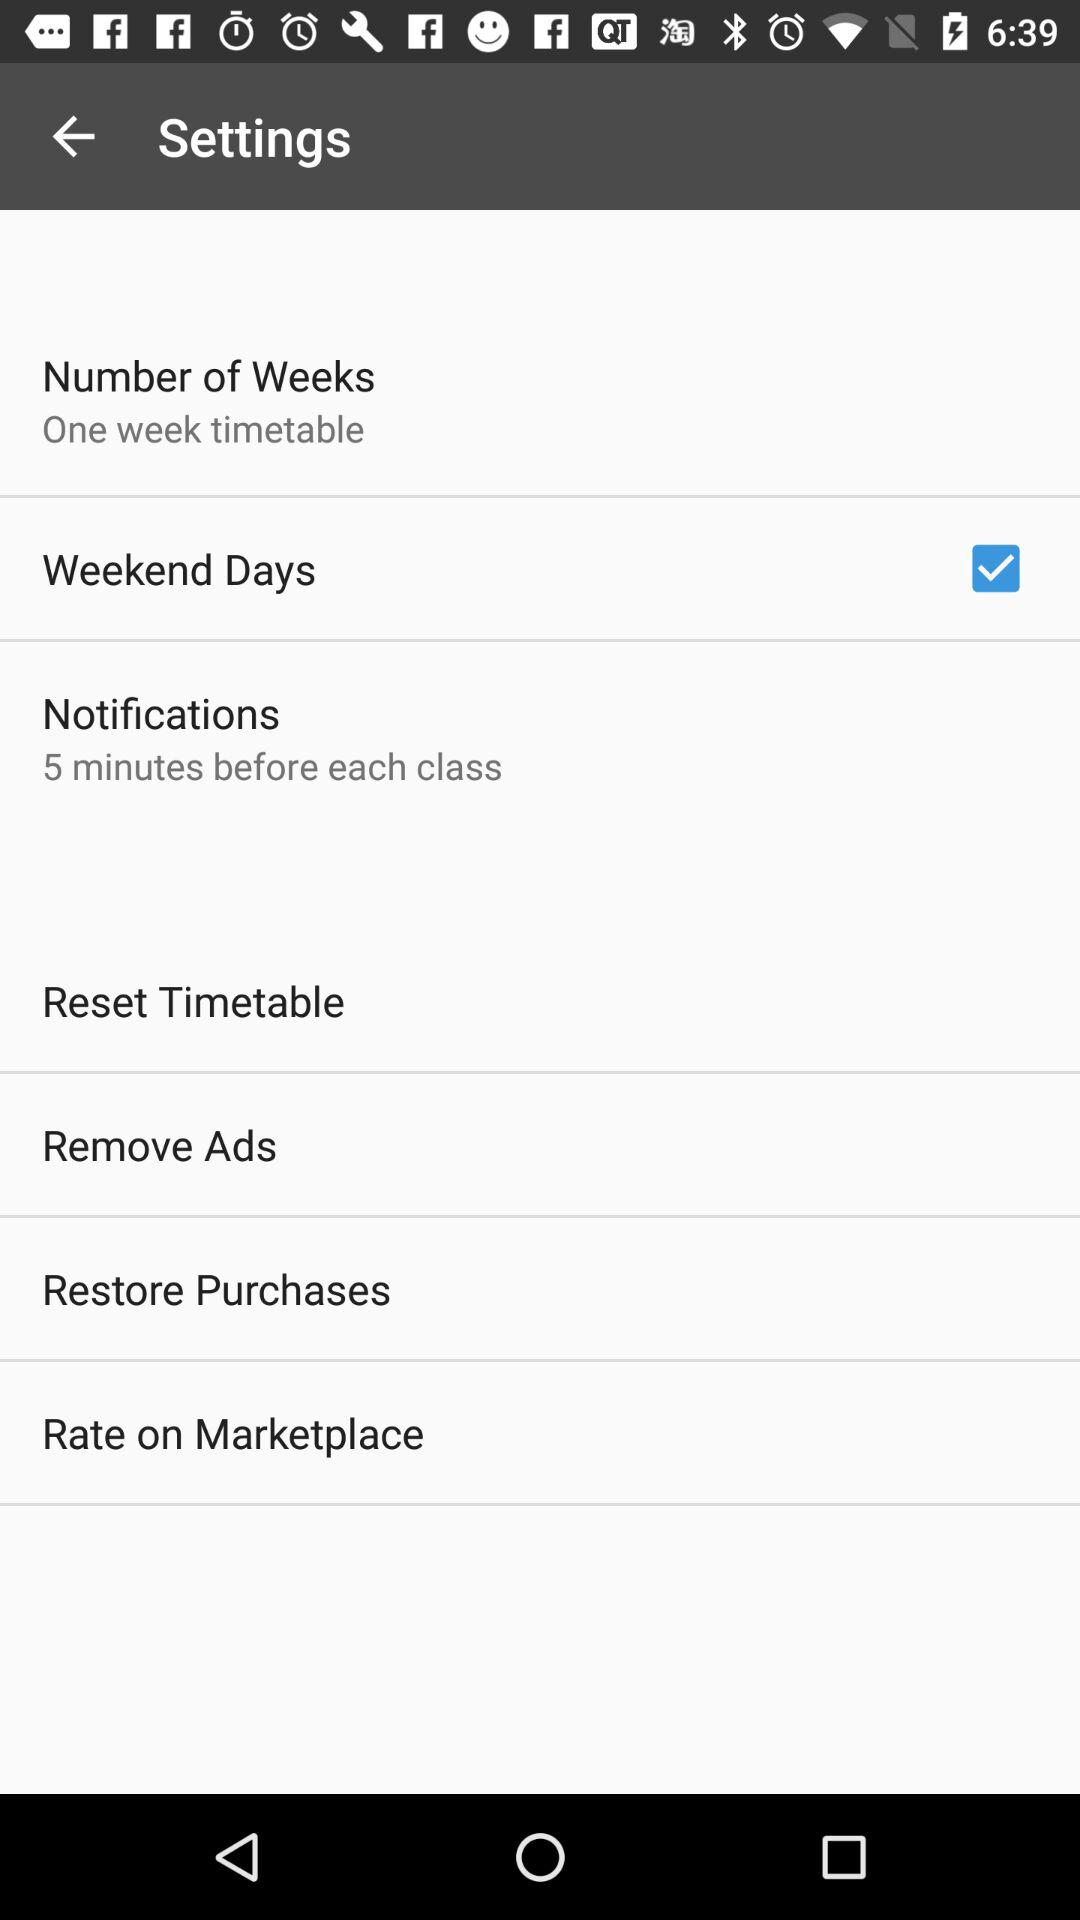What option was selected? The selected option was "Weekend Days". 